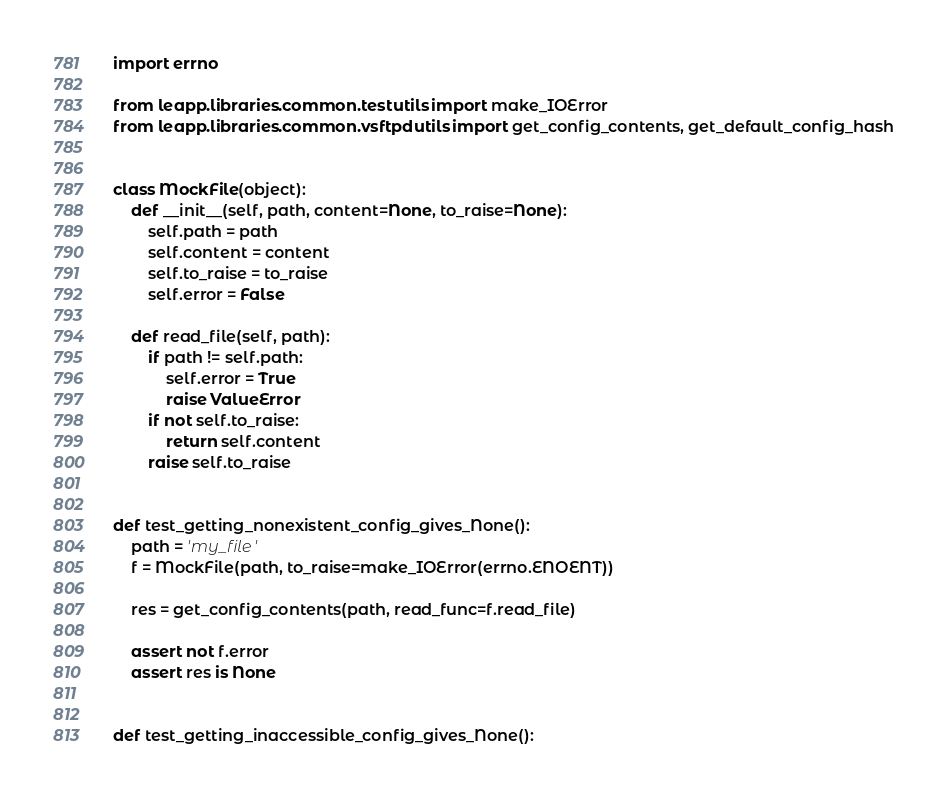<code> <loc_0><loc_0><loc_500><loc_500><_Python_>import errno

from leapp.libraries.common.testutils import make_IOError
from leapp.libraries.common.vsftpdutils import get_config_contents, get_default_config_hash


class MockFile(object):
    def __init__(self, path, content=None, to_raise=None):
        self.path = path
        self.content = content
        self.to_raise = to_raise
        self.error = False

    def read_file(self, path):
        if path != self.path:
            self.error = True
            raise ValueError
        if not self.to_raise:
            return self.content
        raise self.to_raise


def test_getting_nonexistent_config_gives_None():
    path = 'my_file'
    f = MockFile(path, to_raise=make_IOError(errno.ENOENT))

    res = get_config_contents(path, read_func=f.read_file)

    assert not f.error
    assert res is None


def test_getting_inaccessible_config_gives_None():</code> 